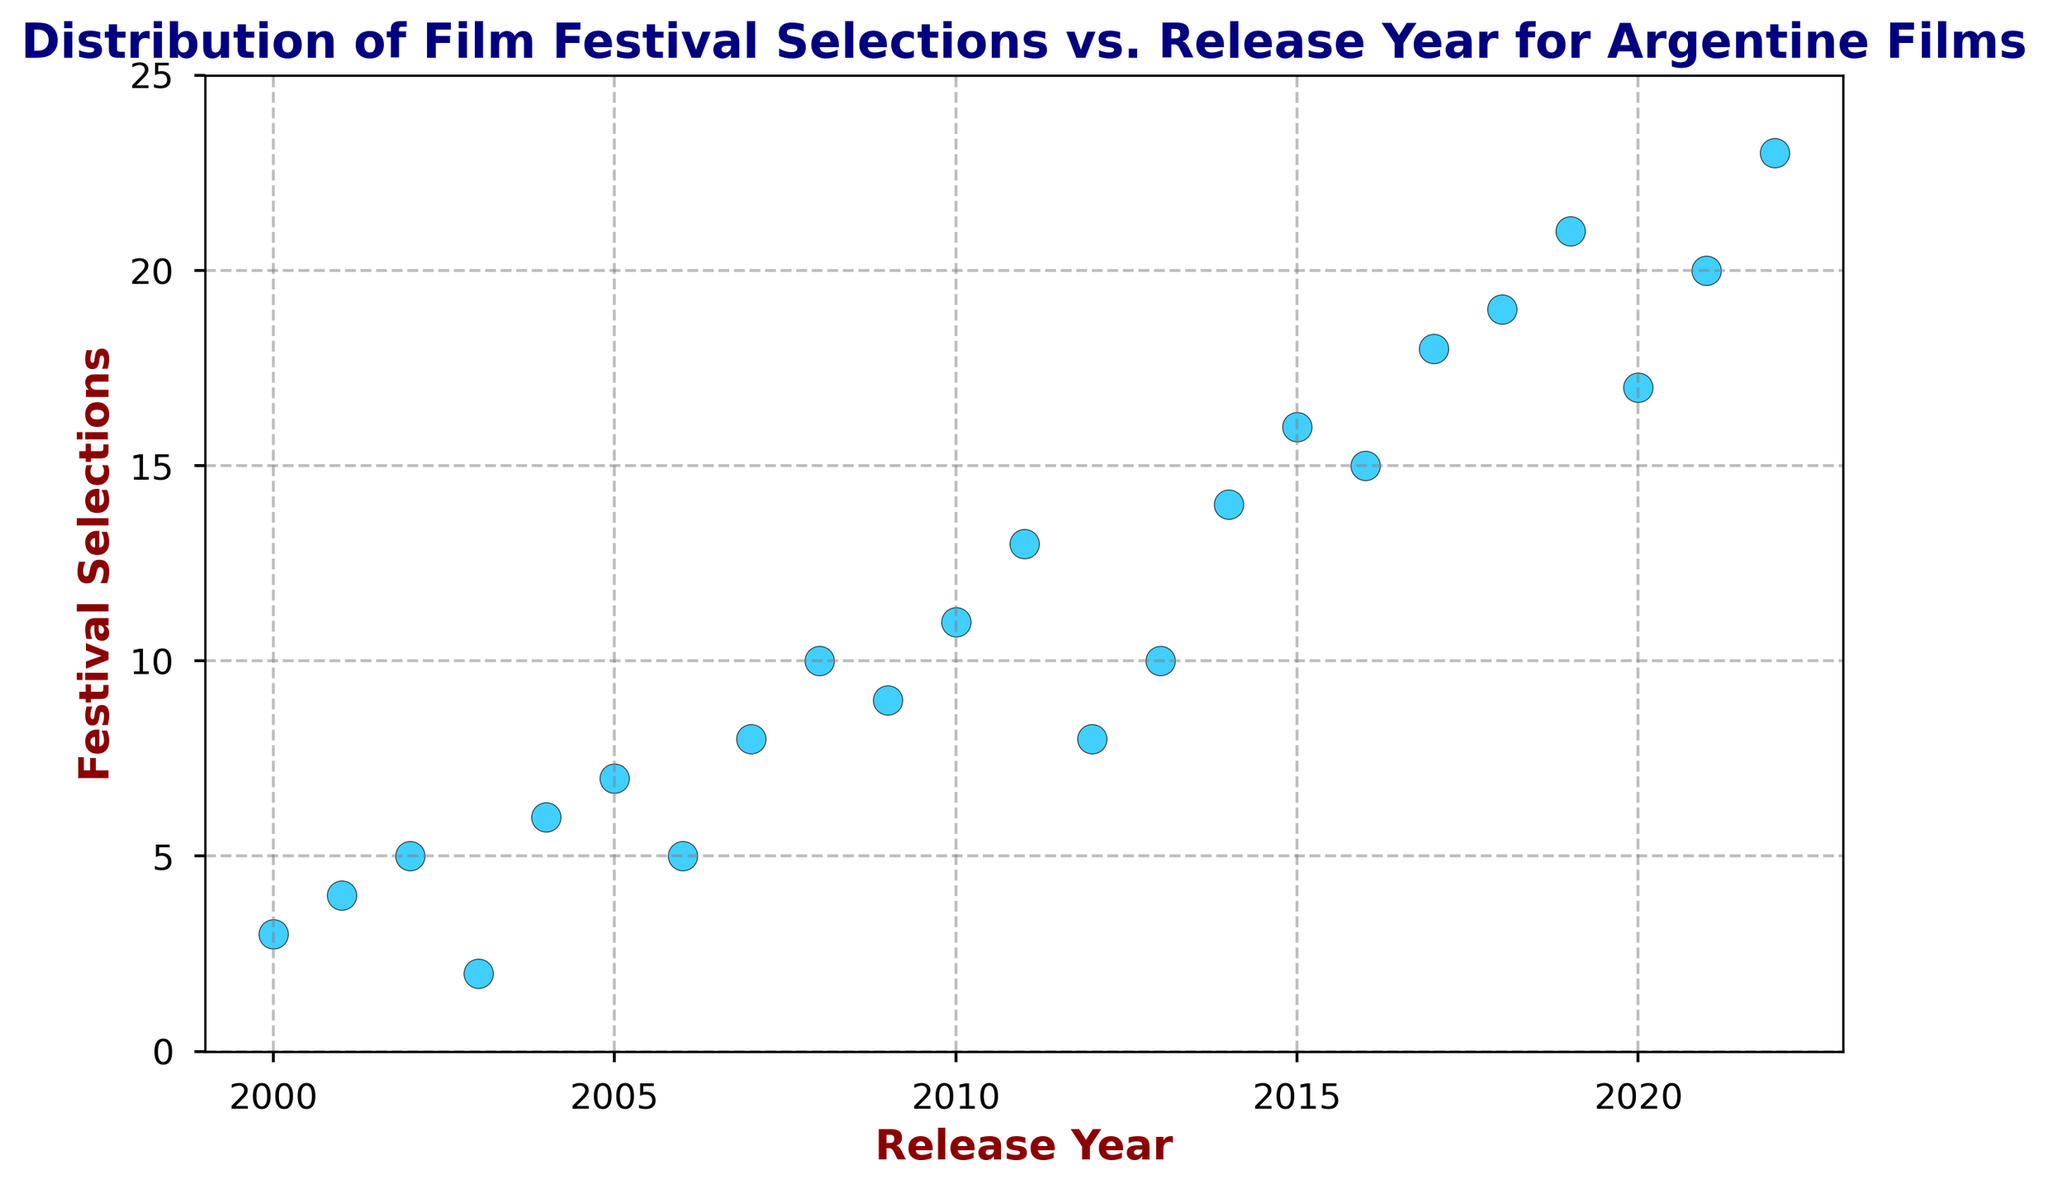What year had the highest number of film festival selections? The scatter plot shows that for each year, the number of festival selections is represented by a point. By finding the highest point on the vertical axis and corresponding to its year on the horizontal axis, we identify 2022 as the year with the most selections.
Answer: 2022 Is the number of festival selections generally increasing over time? Observing the scatter plot, we see that the points tend to ascend from left to right, indicating a general upward trend in the number of festival selections over the years.
Answer: Yes Which two consecutive years had the largest increase in film festival selections? By comparing the height difference between points for each pair of consecutive years, the biggest vertical jump seems to be between 2014 and 2015, from 14 to 16 selections.
Answer: 2014-2015 Are there any years where the number of festival selections is the same? Looking at the scatter plot, all points have distinct vertical positions, meaning no two years have the same number of selections.
Answer: No How does the number of selections in 2010 compare to that in 2020? Referencing the scatter plot, the point for 2010 is at 11 festival selections and for 2020 it's at 17, indicating that 2020 had more selections compared to 2010.
Answer: 2020 had more What is the average number of festival selections per year from 2015 to 2020? Add the festival selections for each year between 2015 and 2020 and divide by the number of years. (16 + 15 + 18 + 19 + 21 + 17) / 6 = 106 / 6 ≈ 17.67
Answer: 17.67 Which years had more than 15 festival selections? Checking each point on the plot, the years with festival selections greater than 15 are 2015, 2017, 2018, 2019, 2020, 2021, and 2022.
Answer: 2015, 2017, 2018, 2019, 2020, 2021, 2022 What is the difference in festival selections between 2004 and 2008? Subtract the number of selections in 2004 (6) from the number of selections in 2008 (10), i.e., 10 - 6 = 4.
Answer: 4 What color represents the data points on the scatter plot? The points in the scatter plot are visually identifiable by their blueish color, specifically deepskyblue.
Answer: Deepskyblue 